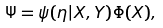<formula> <loc_0><loc_0><loc_500><loc_500>\Psi = \psi ( \eta | X , Y ) \Phi ( X ) ,</formula> 